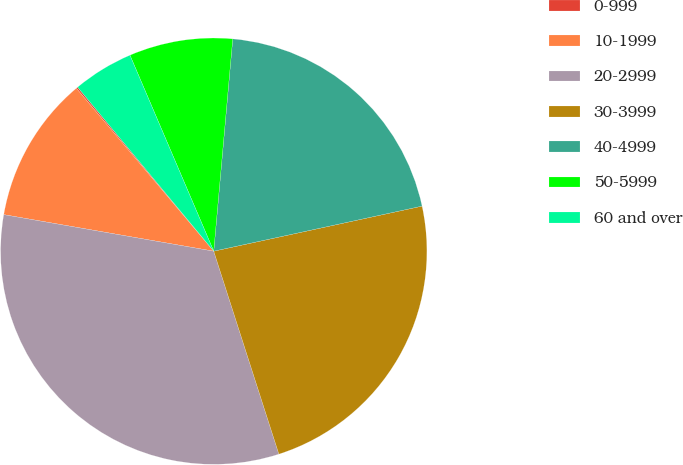<chart> <loc_0><loc_0><loc_500><loc_500><pie_chart><fcel>0-999<fcel>10-1999<fcel>20-2999<fcel>30-3999<fcel>40-4999<fcel>50-5999<fcel>60 and over<nl><fcel>0.12%<fcel>11.11%<fcel>32.69%<fcel>23.45%<fcel>20.19%<fcel>7.85%<fcel>4.6%<nl></chart> 